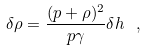<formula> <loc_0><loc_0><loc_500><loc_500>\delta \rho = \frac { ( p + \rho ) ^ { 2 } } { p \gamma } \delta h \ ,</formula> 